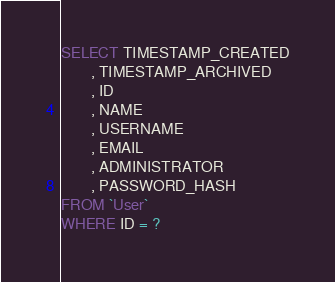<code> <loc_0><loc_0><loc_500><loc_500><_SQL_>SELECT TIMESTAMP_CREATED
        , TIMESTAMP_ARCHIVED
        , ID
        , NAME
        , USERNAME
        , EMAIL
        , ADMINISTRATOR
        , PASSWORD_HASH
FROM `User`
WHERE ID = ?</code> 